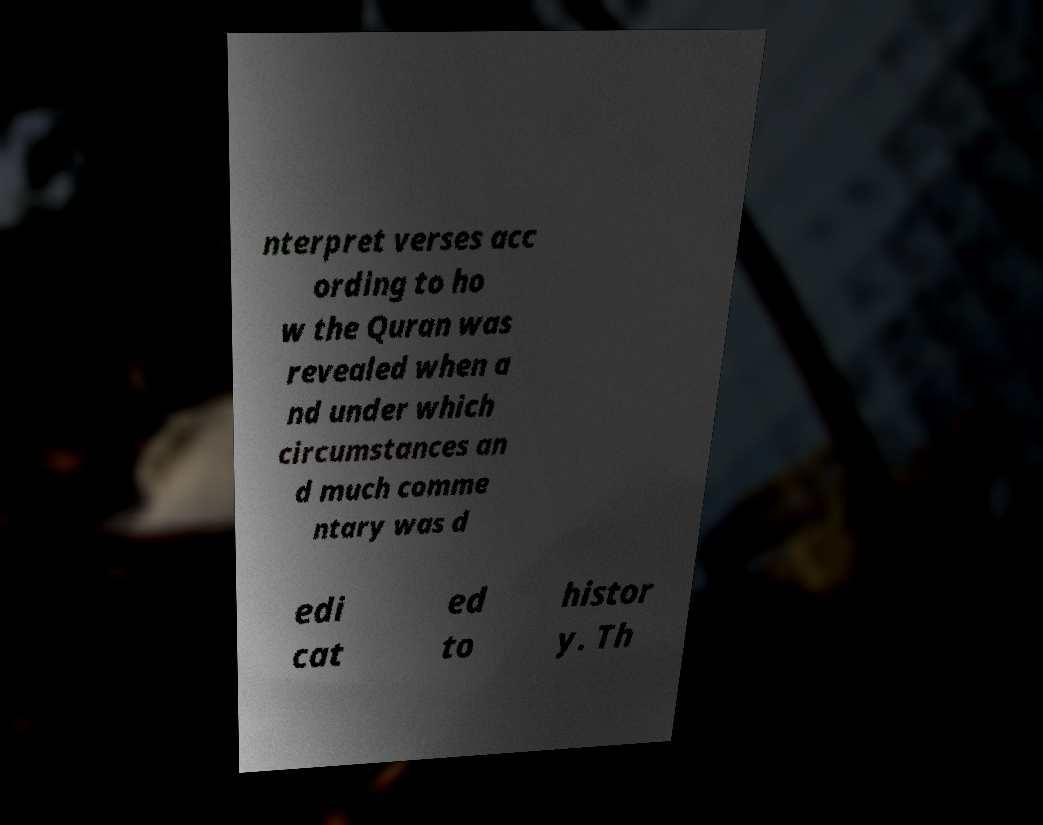Could you extract and type out the text from this image? nterpret verses acc ording to ho w the Quran was revealed when a nd under which circumstances an d much comme ntary was d edi cat ed to histor y. Th 